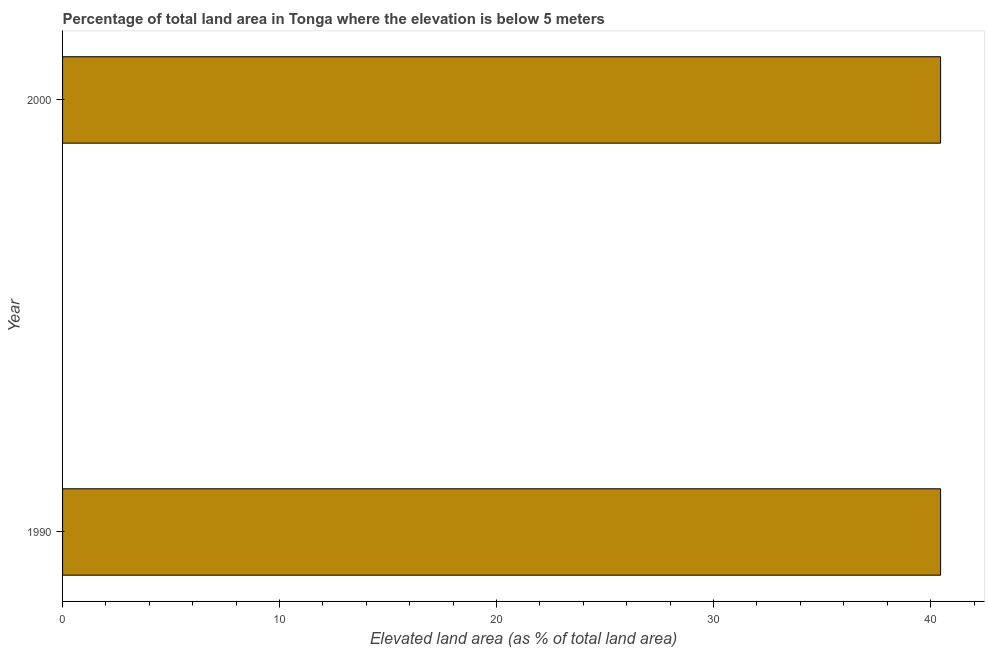What is the title of the graph?
Offer a very short reply. Percentage of total land area in Tonga where the elevation is below 5 meters. What is the label or title of the X-axis?
Provide a short and direct response. Elevated land area (as % of total land area). What is the total elevated land area in 1990?
Keep it short and to the point. 40.46. Across all years, what is the maximum total elevated land area?
Make the answer very short. 40.46. Across all years, what is the minimum total elevated land area?
Offer a terse response. 40.46. What is the sum of the total elevated land area?
Offer a very short reply. 80.92. What is the average total elevated land area per year?
Ensure brevity in your answer.  40.46. What is the median total elevated land area?
Make the answer very short. 40.46. In how many years, is the total elevated land area greater than 18 %?
Offer a very short reply. 2. Do a majority of the years between 1990 and 2000 (inclusive) have total elevated land area greater than 6 %?
Provide a succinct answer. Yes. Is the total elevated land area in 1990 less than that in 2000?
Keep it short and to the point. No. How many bars are there?
Ensure brevity in your answer.  2. Are all the bars in the graph horizontal?
Give a very brief answer. Yes. How many years are there in the graph?
Your answer should be very brief. 2. Are the values on the major ticks of X-axis written in scientific E-notation?
Offer a very short reply. No. What is the Elevated land area (as % of total land area) in 1990?
Make the answer very short. 40.46. What is the Elevated land area (as % of total land area) of 2000?
Give a very brief answer. 40.46. What is the difference between the Elevated land area (as % of total land area) in 1990 and 2000?
Keep it short and to the point. 0. What is the ratio of the Elevated land area (as % of total land area) in 1990 to that in 2000?
Ensure brevity in your answer.  1. 